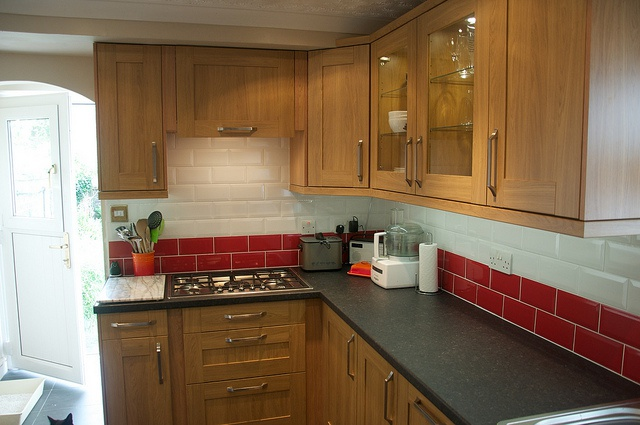Describe the objects in this image and their specific colors. I can see oven in gray, black, and maroon tones, sink in gray, black, darkgray, and lightblue tones, wine glass in gray, olive, maroon, and tan tones, wine glass in gray, olive, and white tones, and spoon in gray, black, and darkgreen tones in this image. 